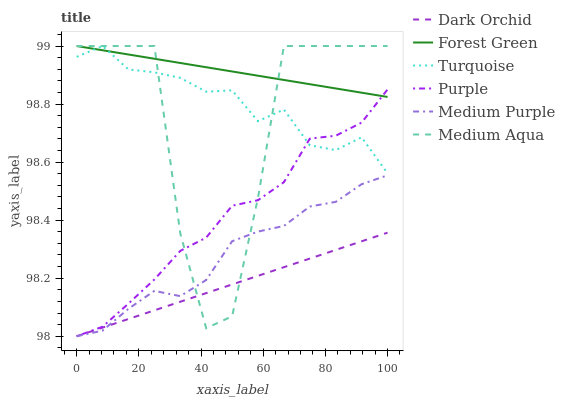Does Dark Orchid have the minimum area under the curve?
Answer yes or no. Yes. Does Forest Green have the maximum area under the curve?
Answer yes or no. Yes. Does Purple have the minimum area under the curve?
Answer yes or no. No. Does Purple have the maximum area under the curve?
Answer yes or no. No. Is Forest Green the smoothest?
Answer yes or no. Yes. Is Medium Aqua the roughest?
Answer yes or no. Yes. Is Purple the smoothest?
Answer yes or no. No. Is Purple the roughest?
Answer yes or no. No. Does Purple have the lowest value?
Answer yes or no. Yes. Does Forest Green have the lowest value?
Answer yes or no. No. Does Medium Aqua have the highest value?
Answer yes or no. Yes. Does Purple have the highest value?
Answer yes or no. No. Is Dark Orchid less than Forest Green?
Answer yes or no. Yes. Is Turquoise greater than Medium Purple?
Answer yes or no. Yes. Does Purple intersect Forest Green?
Answer yes or no. Yes. Is Purple less than Forest Green?
Answer yes or no. No. Is Purple greater than Forest Green?
Answer yes or no. No. Does Dark Orchid intersect Forest Green?
Answer yes or no. No. 